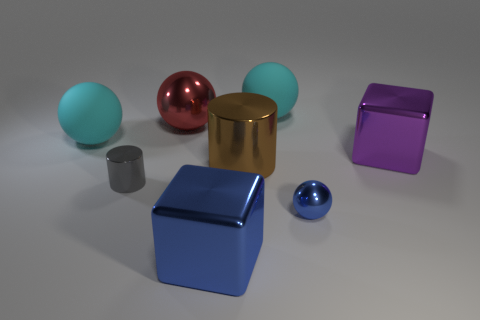How does the lighting in the image affect the appearance of the objects? The lighting in the image is soft and appears to be coming from above, casting gentle shadows beneath each object. This illumination accentuates the shiny textures of the metallic surfaces, producing subtle reflections and highlights that give a sense of the three-dimensionality of the objects. 